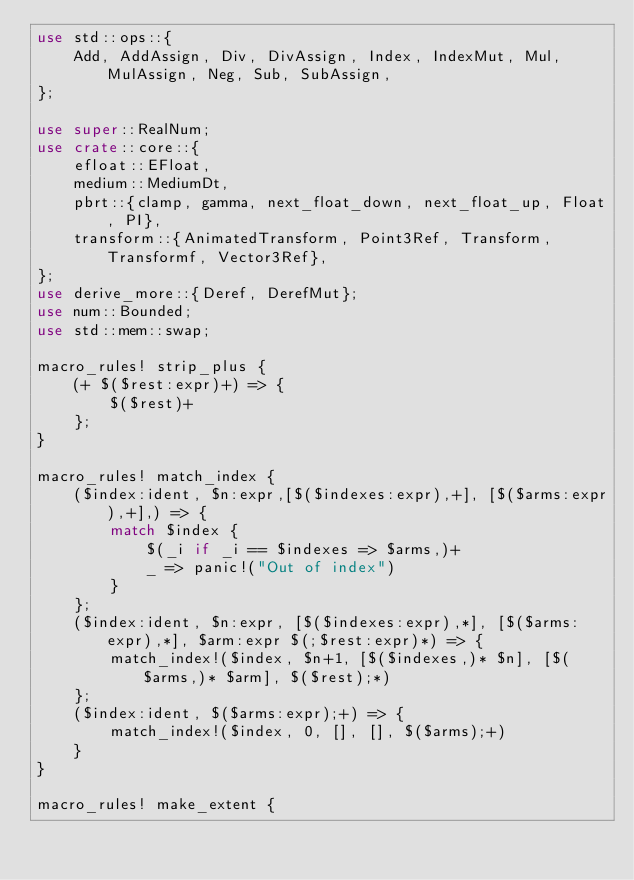Convert code to text. <code><loc_0><loc_0><loc_500><loc_500><_Rust_>use std::ops::{
    Add, AddAssign, Div, DivAssign, Index, IndexMut, Mul, MulAssign, Neg, Sub, SubAssign,
};

use super::RealNum;
use crate::core::{
    efloat::EFloat,
    medium::MediumDt,
    pbrt::{clamp, gamma, next_float_down, next_float_up, Float, PI},
    transform::{AnimatedTransform, Point3Ref, Transform, Transformf, Vector3Ref},
};
use derive_more::{Deref, DerefMut};
use num::Bounded;
use std::mem::swap;

macro_rules! strip_plus {
    (+ $($rest:expr)+) => {
        $($rest)+
    };
}

macro_rules! match_index {
    ($index:ident, $n:expr,[$($indexes:expr),+], [$($arms:expr),+],) => {
        match $index {
            $(_i if _i == $indexes => $arms,)+
            _ => panic!("Out of index")
        }
    };
    ($index:ident, $n:expr, [$($indexes:expr),*], [$($arms:expr),*], $arm:expr $(;$rest:expr)*) => {
        match_index!($index, $n+1, [$($indexes,)* $n], [$($arms,)* $arm], $($rest);*)
    };
    ($index:ident, $($arms:expr);+) => {
        match_index!($index, 0, [], [], $($arms);+)
    }
}

macro_rules! make_extent {</code> 